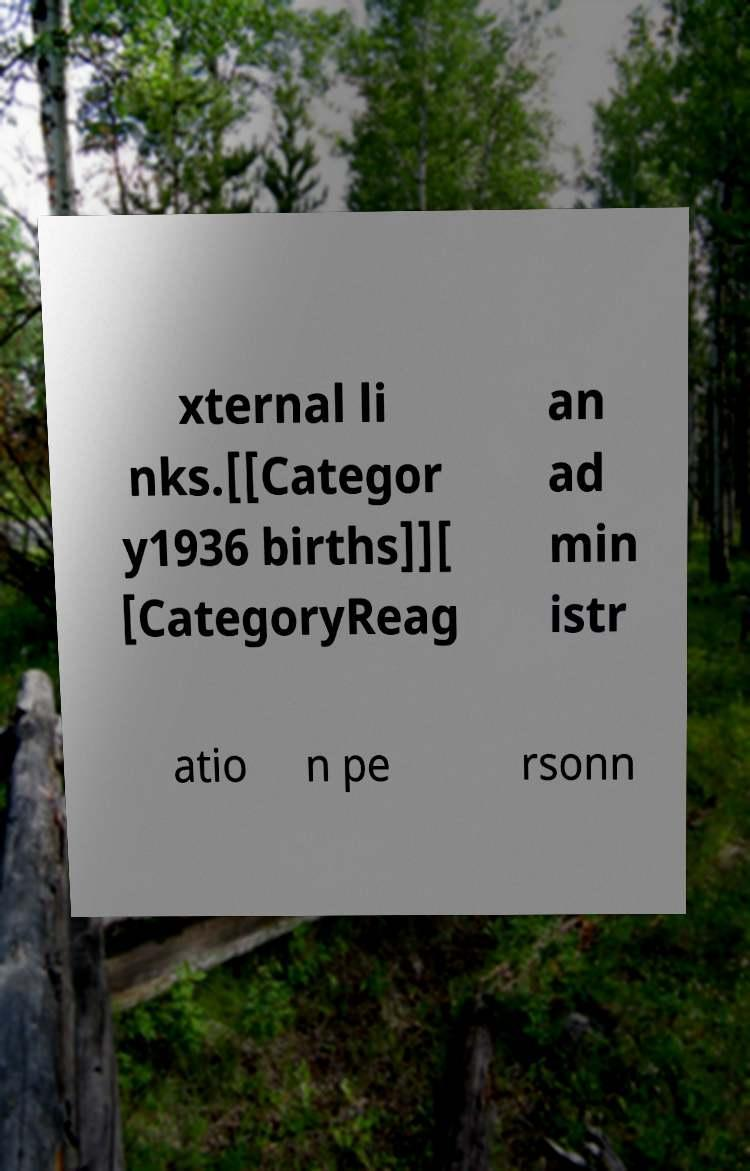What messages or text are displayed in this image? I need them in a readable, typed format. xternal li nks.[[Categor y1936 births]][ [CategoryReag an ad min istr atio n pe rsonn 